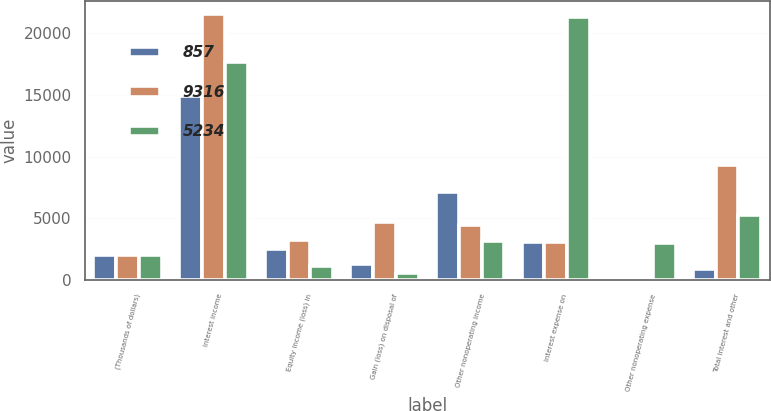<chart> <loc_0><loc_0><loc_500><loc_500><stacked_bar_chart><ecel><fcel>(Thousands of dollars)<fcel>Interest income<fcel>Equity income (loss) in<fcel>Gain (loss) on disposal of<fcel>Other nonoperating income<fcel>Interest expense on<fcel>Other nonoperating expense<fcel>Total interest and other<nl><fcel>857<fcel>2005<fcel>14886<fcel>2511<fcel>1308<fcel>7153<fcel>3099<fcel>1<fcel>857<nl><fcel>9316<fcel>2004<fcel>21534<fcel>3225<fcel>4725<fcel>4441<fcel>3099<fcel>8<fcel>9316<nl><fcel>5234<fcel>2003<fcel>17653<fcel>1108<fcel>581<fcel>3160<fcel>21320<fcel>3038<fcel>5234<nl></chart> 